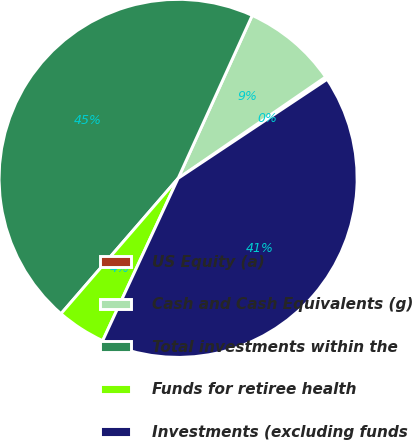Convert chart to OTSL. <chart><loc_0><loc_0><loc_500><loc_500><pie_chart><fcel>US Equity (a)<fcel>Cash and Cash Equivalents (g)<fcel>Total investments within the<fcel>Funds for retiree health<fcel>Investments (excluding funds<nl><fcel>0.25%<fcel>8.62%<fcel>45.44%<fcel>4.43%<fcel>41.26%<nl></chart> 